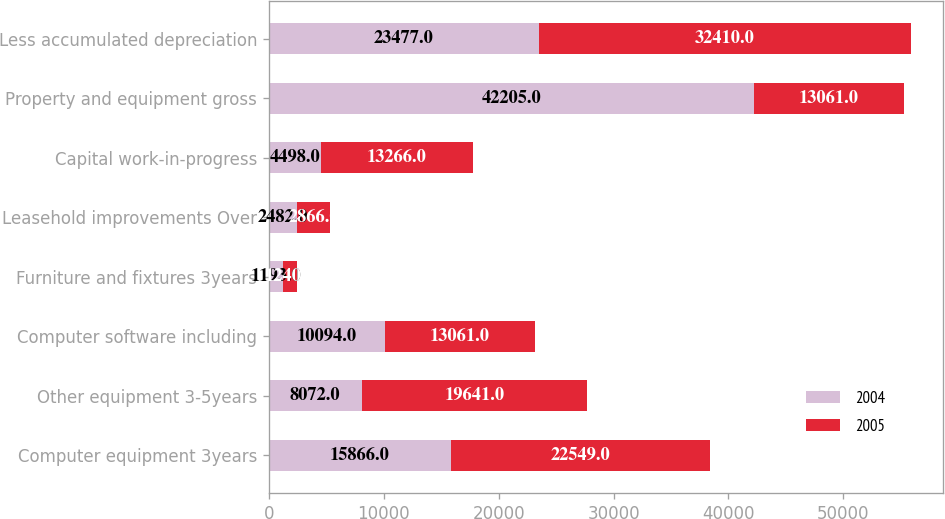<chart> <loc_0><loc_0><loc_500><loc_500><stacked_bar_chart><ecel><fcel>Computer equipment 3years<fcel>Other equipment 3-5years<fcel>Computer software including<fcel>Furniture and fixtures 3years<fcel>Leasehold improvements Over<fcel>Capital work-in-progress<fcel>Property and equipment gross<fcel>Less accumulated depreciation<nl><fcel>2004<fcel>15866<fcel>8072<fcel>10094<fcel>1193<fcel>2482<fcel>4498<fcel>42205<fcel>23477<nl><fcel>2005<fcel>22549<fcel>19641<fcel>13061<fcel>1240<fcel>2866<fcel>13266<fcel>13061<fcel>32410<nl></chart> 